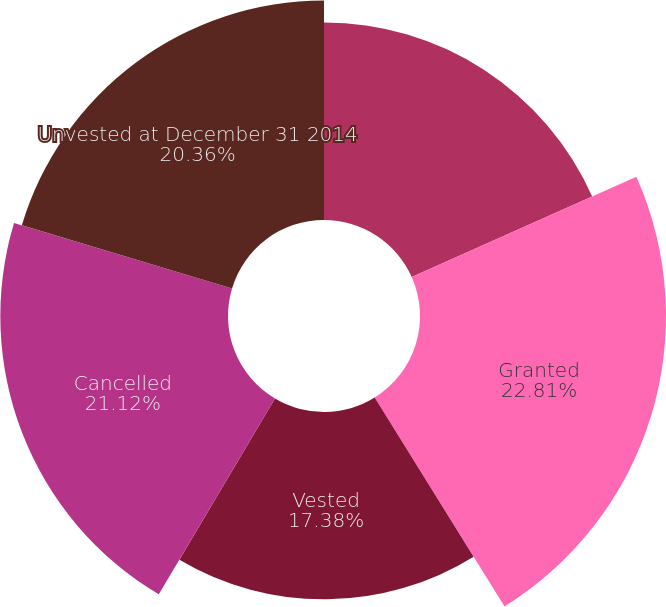<chart> <loc_0><loc_0><loc_500><loc_500><pie_chart><fcel>Unvested at January 1 2014<fcel>Granted<fcel>Vested<fcel>Cancelled<fcel>Unvested at December 31 2014<nl><fcel>18.33%<fcel>22.82%<fcel>17.38%<fcel>21.12%<fcel>20.36%<nl></chart> 